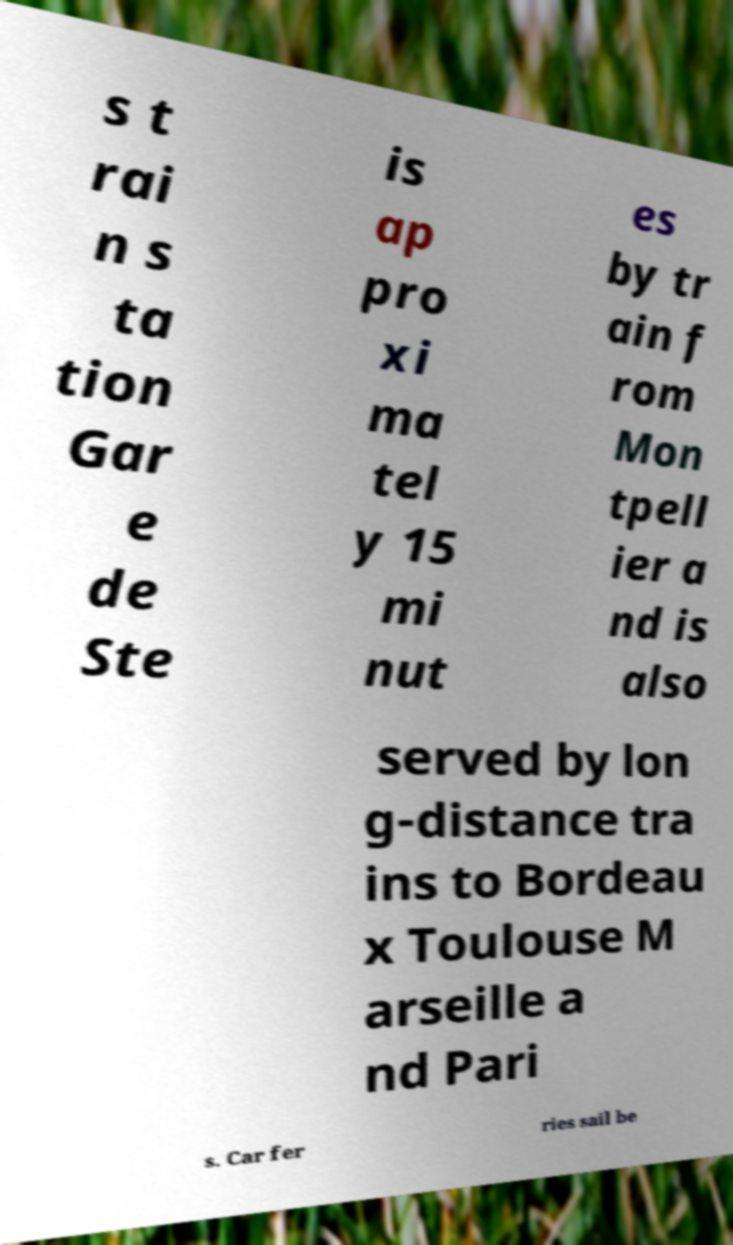For documentation purposes, I need the text within this image transcribed. Could you provide that? s t rai n s ta tion Gar e de Ste is ap pro xi ma tel y 15 mi nut es by tr ain f rom Mon tpell ier a nd is also served by lon g-distance tra ins to Bordeau x Toulouse M arseille a nd Pari s. Car fer ries sail be 